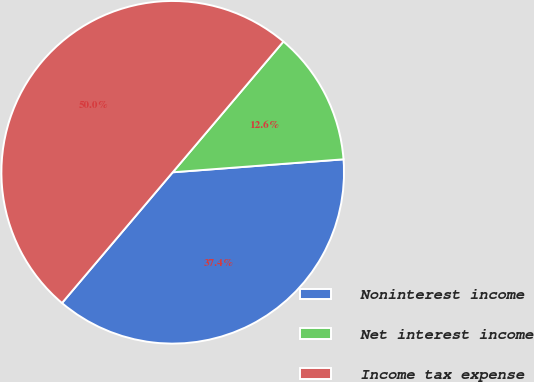Convert chart to OTSL. <chart><loc_0><loc_0><loc_500><loc_500><pie_chart><fcel>Noninterest income<fcel>Net interest income<fcel>Income tax expense<nl><fcel>37.39%<fcel>12.61%<fcel>50.0%<nl></chart> 